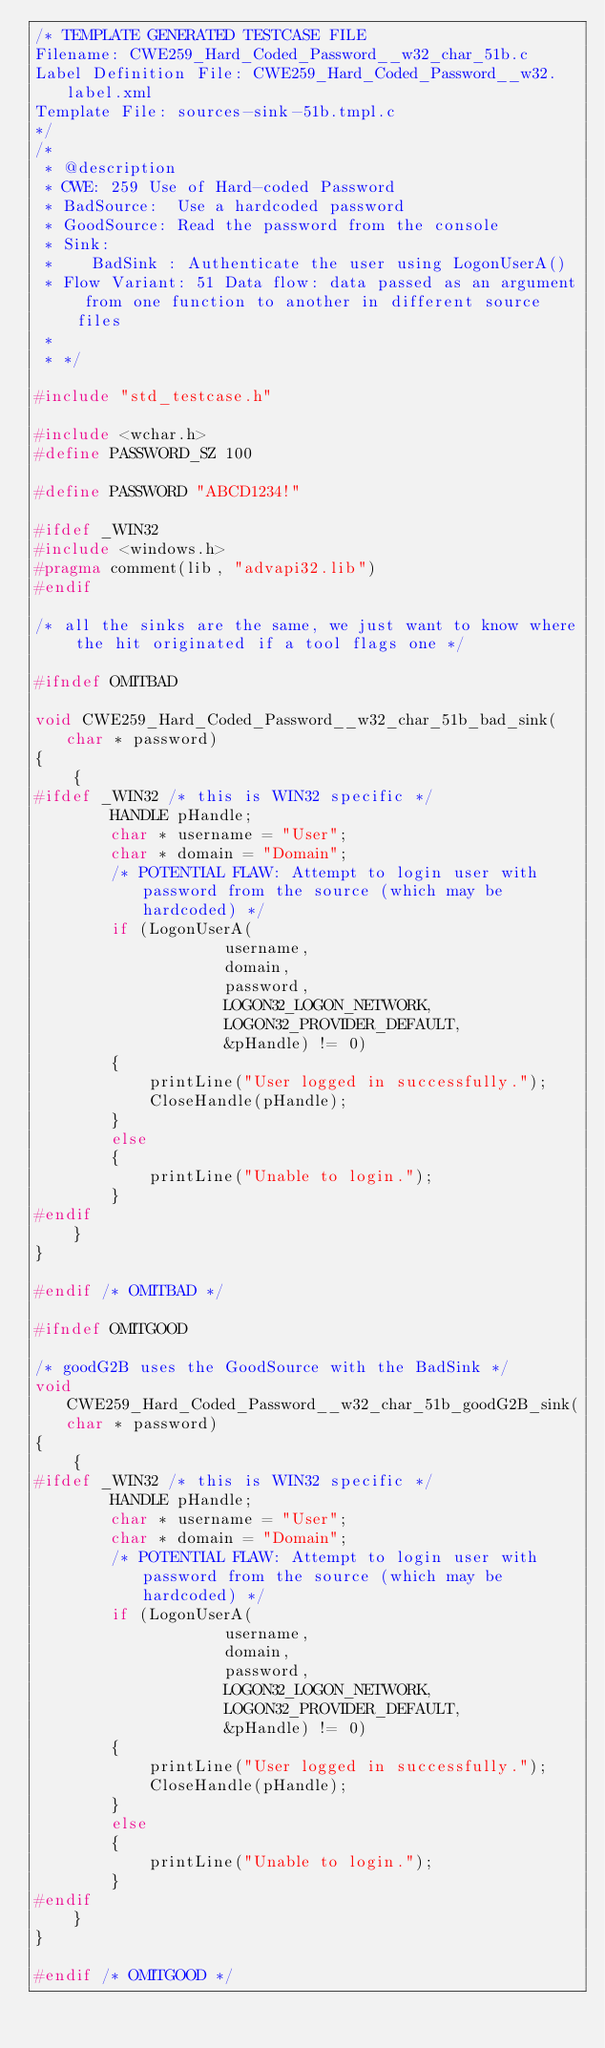<code> <loc_0><loc_0><loc_500><loc_500><_C_>/* TEMPLATE GENERATED TESTCASE FILE
Filename: CWE259_Hard_Coded_Password__w32_char_51b.c
Label Definition File: CWE259_Hard_Coded_Password__w32.label.xml
Template File: sources-sink-51b.tmpl.c
*/
/*
 * @description
 * CWE: 259 Use of Hard-coded Password
 * BadSource:  Use a hardcoded password
 * GoodSource: Read the password from the console
 * Sink:
 *    BadSink : Authenticate the user using LogonUserA()
 * Flow Variant: 51 Data flow: data passed as an argument from one function to another in different source files
 *
 * */

#include "std_testcase.h"

#include <wchar.h>
#define PASSWORD_SZ 100

#define PASSWORD "ABCD1234!"

#ifdef _WIN32
#include <windows.h>
#pragma comment(lib, "advapi32.lib")
#endif

/* all the sinks are the same, we just want to know where the hit originated if a tool flags one */

#ifndef OMITBAD

void CWE259_Hard_Coded_Password__w32_char_51b_bad_sink(char * password)
{
    {
#ifdef _WIN32 /* this is WIN32 specific */
        HANDLE pHandle;
        char * username = "User";
        char * domain = "Domain";
        /* POTENTIAL FLAW: Attempt to login user with password from the source (which may be hardcoded) */
        if (LogonUserA(
                    username,
                    domain,
                    password,
                    LOGON32_LOGON_NETWORK,
                    LOGON32_PROVIDER_DEFAULT,
                    &pHandle) != 0)
        {
            printLine("User logged in successfully.");
            CloseHandle(pHandle);
        }
        else
        {
            printLine("Unable to login.");
        }
#endif
    }
}

#endif /* OMITBAD */

#ifndef OMITGOOD

/* goodG2B uses the GoodSource with the BadSink */
void CWE259_Hard_Coded_Password__w32_char_51b_goodG2B_sink(char * password)
{
    {
#ifdef _WIN32 /* this is WIN32 specific */
        HANDLE pHandle;
        char * username = "User";
        char * domain = "Domain";
        /* POTENTIAL FLAW: Attempt to login user with password from the source (which may be hardcoded) */
        if (LogonUserA(
                    username,
                    domain,
                    password,
                    LOGON32_LOGON_NETWORK,
                    LOGON32_PROVIDER_DEFAULT,
                    &pHandle) != 0)
        {
            printLine("User logged in successfully.");
            CloseHandle(pHandle);
        }
        else
        {
            printLine("Unable to login.");
        }
#endif
    }
}

#endif /* OMITGOOD */
</code> 